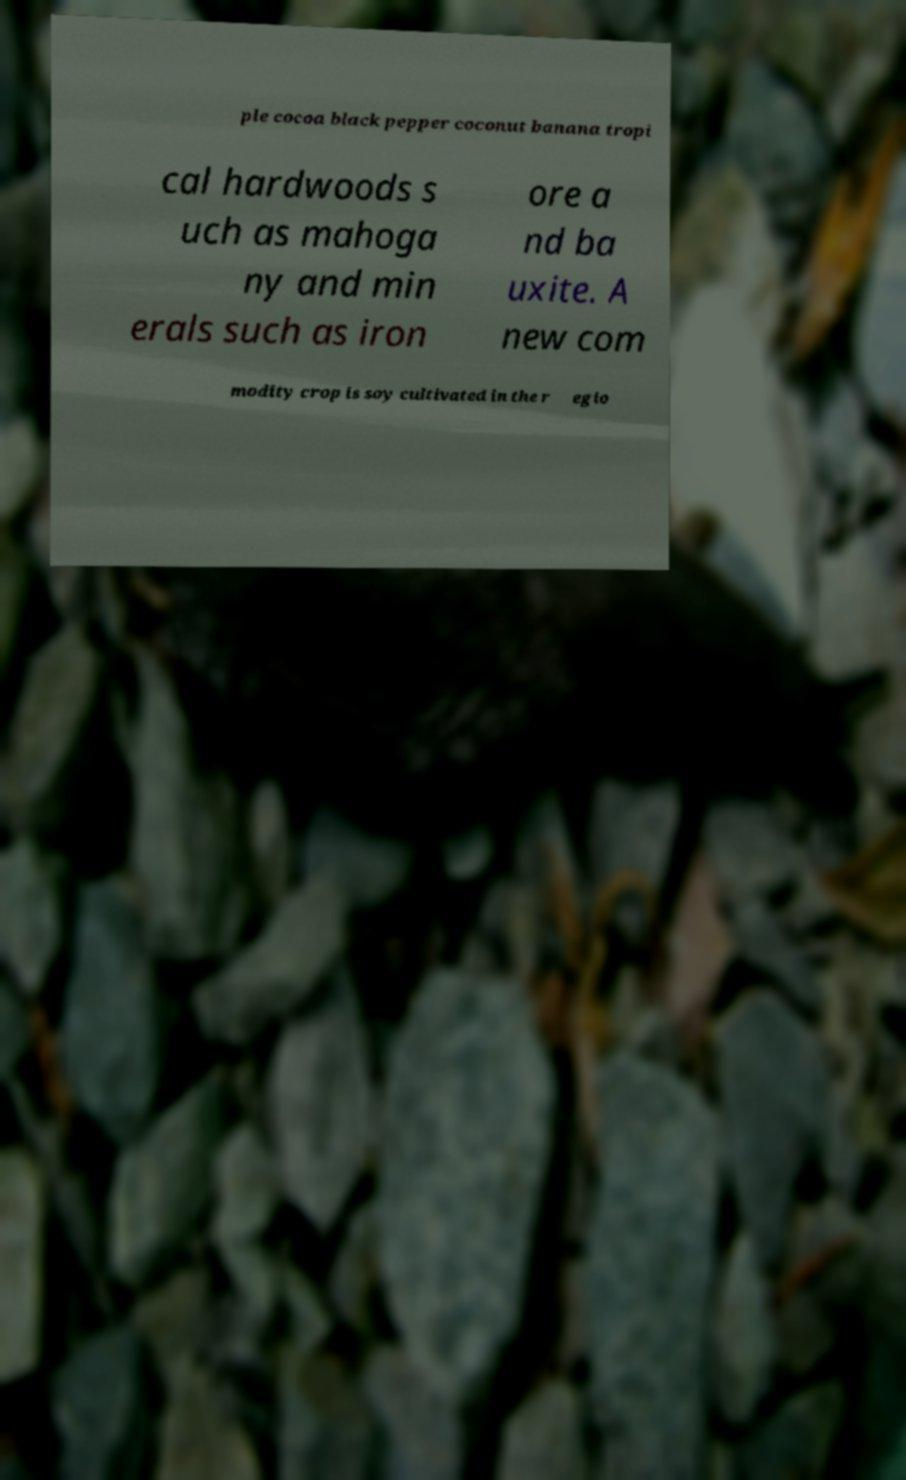Could you extract and type out the text from this image? ple cocoa black pepper coconut banana tropi cal hardwoods s uch as mahoga ny and min erals such as iron ore a nd ba uxite. A new com modity crop is soy cultivated in the r egio 